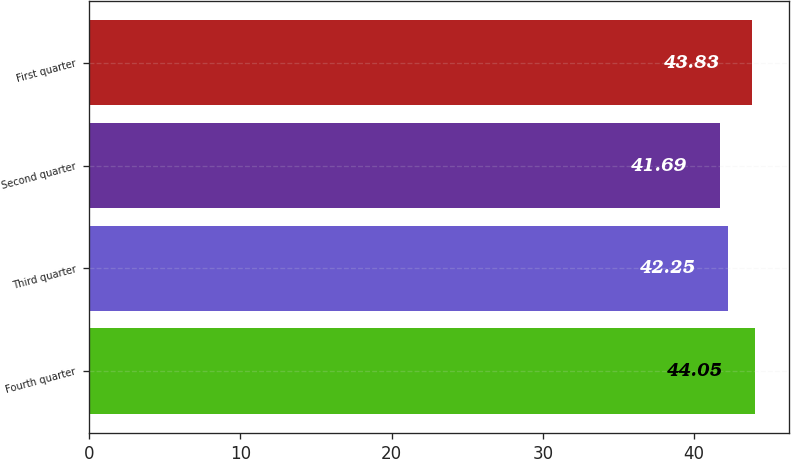Convert chart to OTSL. <chart><loc_0><loc_0><loc_500><loc_500><bar_chart><fcel>Fourth quarter<fcel>Third quarter<fcel>Second quarter<fcel>First quarter<nl><fcel>44.05<fcel>42.25<fcel>41.69<fcel>43.83<nl></chart> 